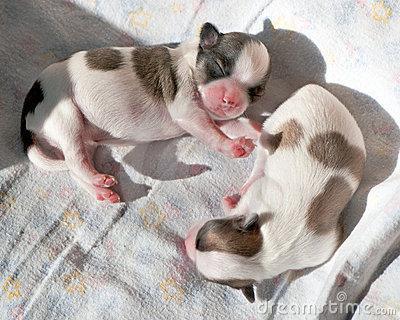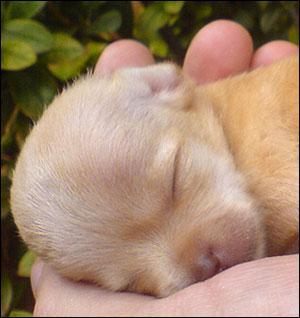The first image is the image on the left, the second image is the image on the right. For the images displayed, is the sentence "At least one chihuahua is sleeping on its back on a cozy blanket." factually correct? Answer yes or no. No. The first image is the image on the left, the second image is the image on the right. Evaluate the accuracy of this statement regarding the images: "The left image shows two chihuahuas in sleeping poses side-by-side, and the right image shows one snoozing chihuahua on solid-colored fabric.". Is it true? Answer yes or no. No. 